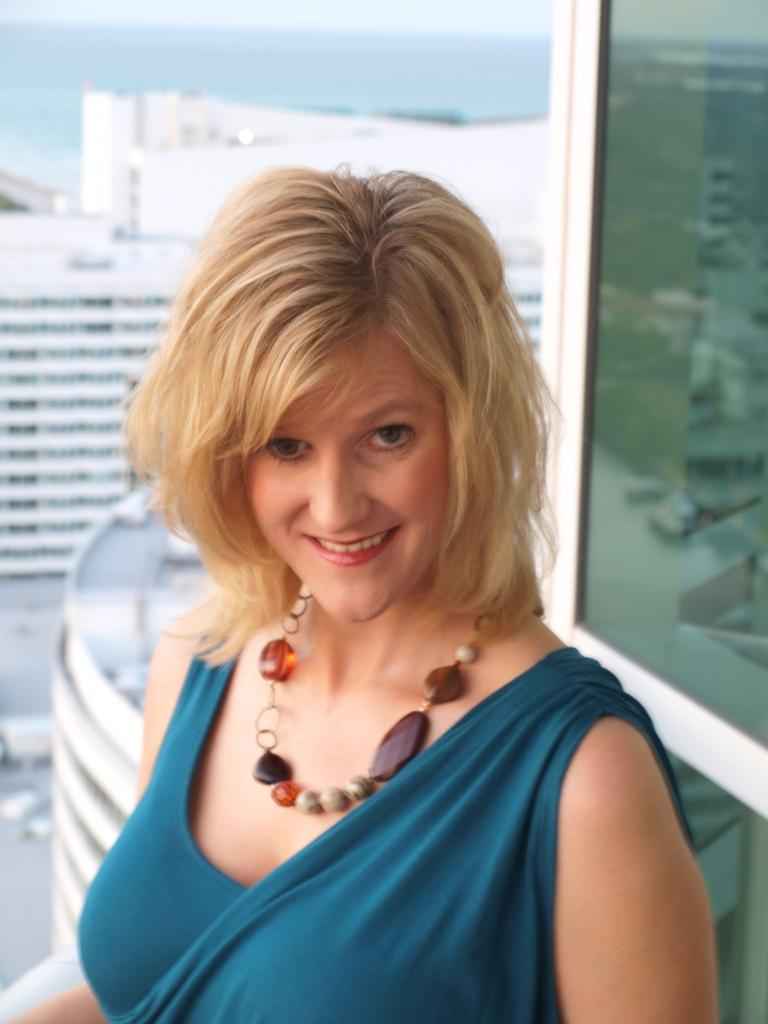Who is the main subject in the image? There is a woman in the center of the image. What is the woman doing in the image? The woman is smiling. What is the woman wearing in the image? The woman is wearing a different costume. What can be seen in the background of the image? There are buildings, glass, and a few other objects visible in the background. What type of vessel can be seen sailing in the background of the image? There is no vessel visible in the background of the image. How does the woman's laugh sound in the image? The image does not capture any sound, so we cannot determine how the woman's laugh sounds. 